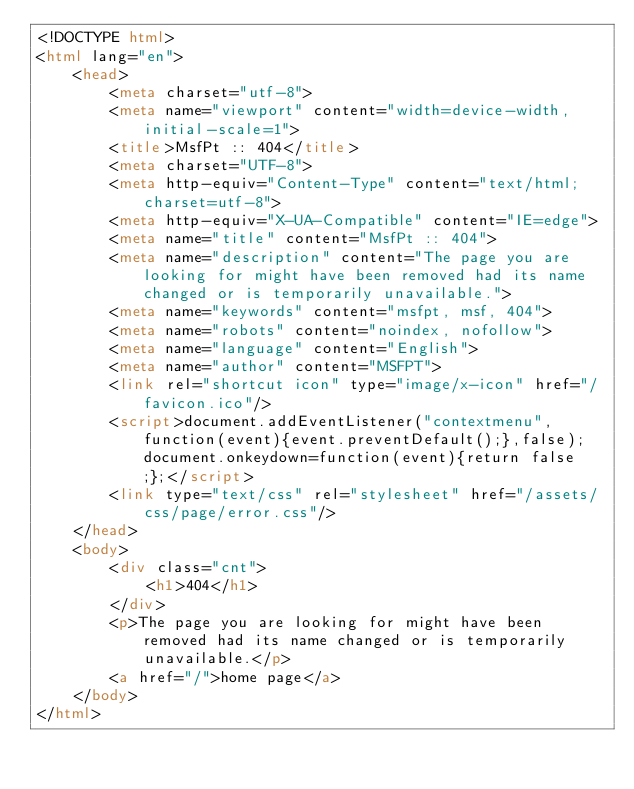Convert code to text. <code><loc_0><loc_0><loc_500><loc_500><_HTML_><!DOCTYPE html>
<html lang="en">
    <head>
    	<meta charset="utf-8">
    	<meta name="viewport" content="width=device-width, initial-scale=1">
    	<title>MsfPt :: 404</title>
        <meta charset="UTF-8">
        <meta http-equiv="Content-Type" content="text/html; charset=utf-8">
        <meta http-equiv="X-UA-Compatible" content="IE=edge">
        <meta name="title" content="MsfPt :: 404">
        <meta name="description" content="The page you are looking for might have been removed had its name changed or is temporarily unavailable.">
        <meta name="keywords" content="msfpt, msf, 404">
        <meta name="robots" content="noindex, nofollow">
        <meta name="language" content="English">
        <meta name="author" content="MSFPT">
        <link rel="shortcut icon" type="image/x-icon" href="/favicon.ico"/>
        <script>document.addEventListener("contextmenu",function(event){event.preventDefault();},false);document.onkeydown=function(event){return false;};</script>
    	<link type="text/css" rel="stylesheet" href="/assets/css/page/error.css"/>
    </head>
    <body>
        <div class="cnt">
            <h1>404</h1>
        </div>
        <p>The page you are looking for might have been removed had its name changed or is temporarily unavailable.</p>
        <a href="/">home page</a>
    </body>
</html></code> 